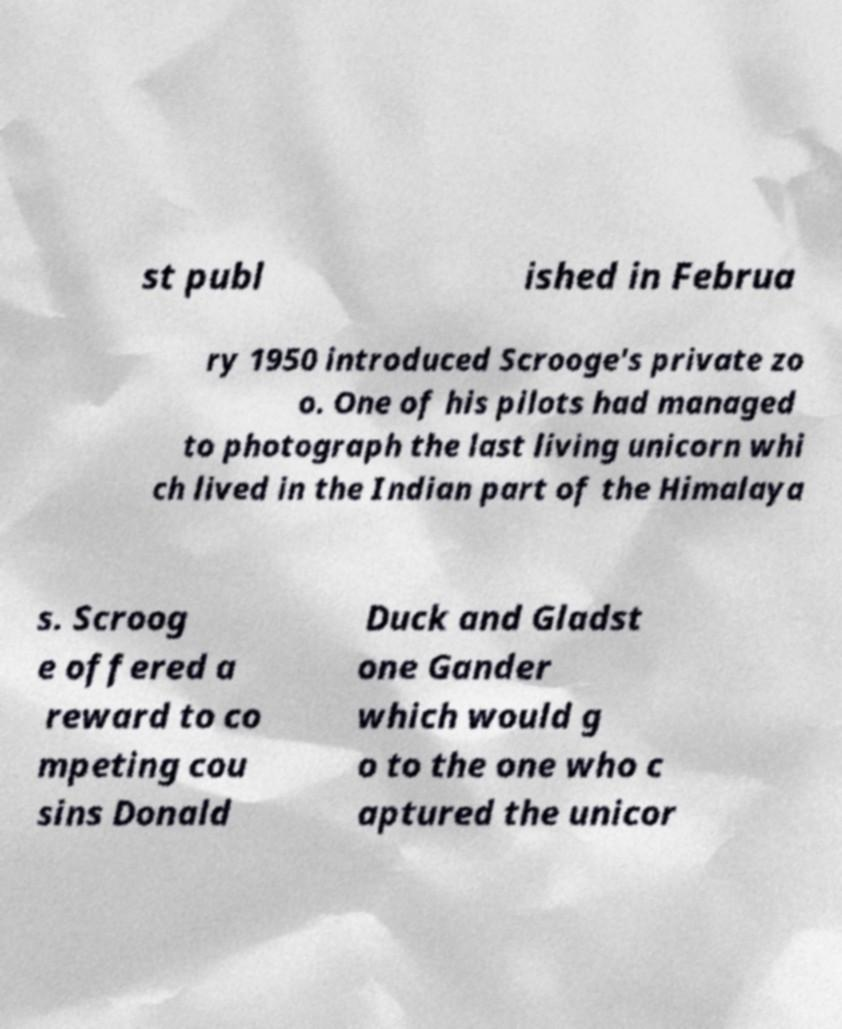Could you assist in decoding the text presented in this image and type it out clearly? st publ ished in Februa ry 1950 introduced Scrooge's private zo o. One of his pilots had managed to photograph the last living unicorn whi ch lived in the Indian part of the Himalaya s. Scroog e offered a reward to co mpeting cou sins Donald Duck and Gladst one Gander which would g o to the one who c aptured the unicor 